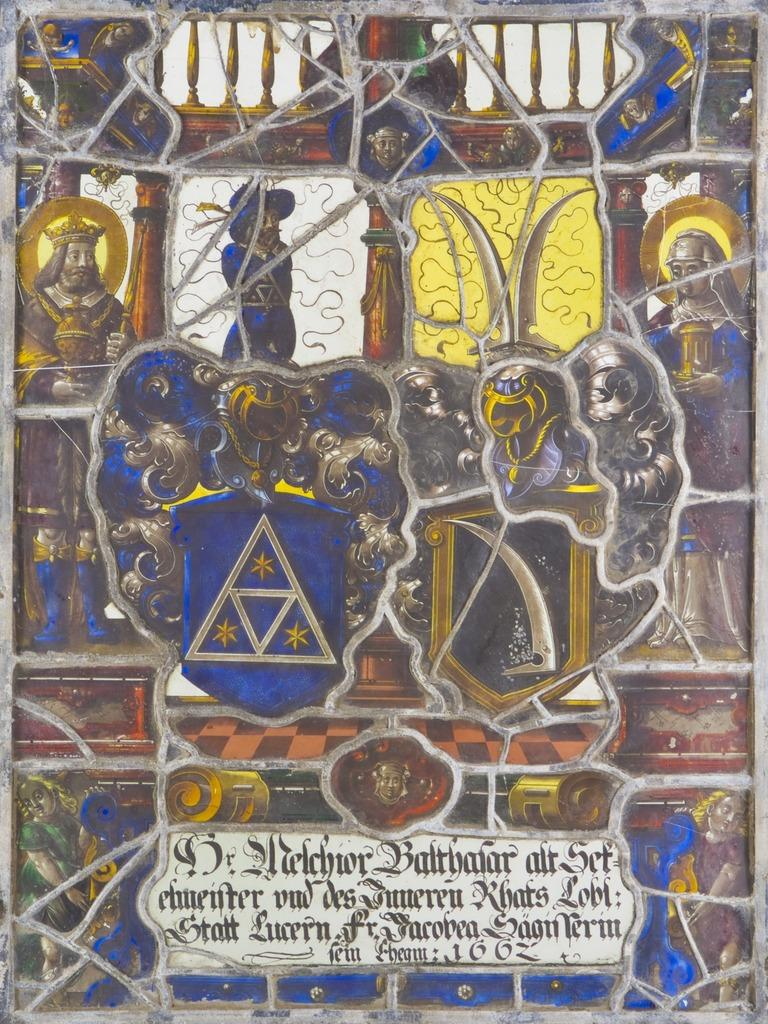What type of artwork is depicted in the image? The image is a sculpture. What colors are used in the sculpture? The sculpture has black and yellow colors. What subjects are featured on the sculpture? There are images of kings on the sculpture. Are there any words or letters on the sculpture? Yes, there is text written on the sculpture. How fast do the trains run in the image? There are no trains present in the image; it is a sculpture featuring images of kings and text. 